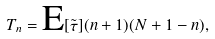Convert formula to latex. <formula><loc_0><loc_0><loc_500><loc_500>T _ { n } = \text {E} [ \tilde { \tau } ] ( n + 1 ) ( N + 1 - n ) ,</formula> 